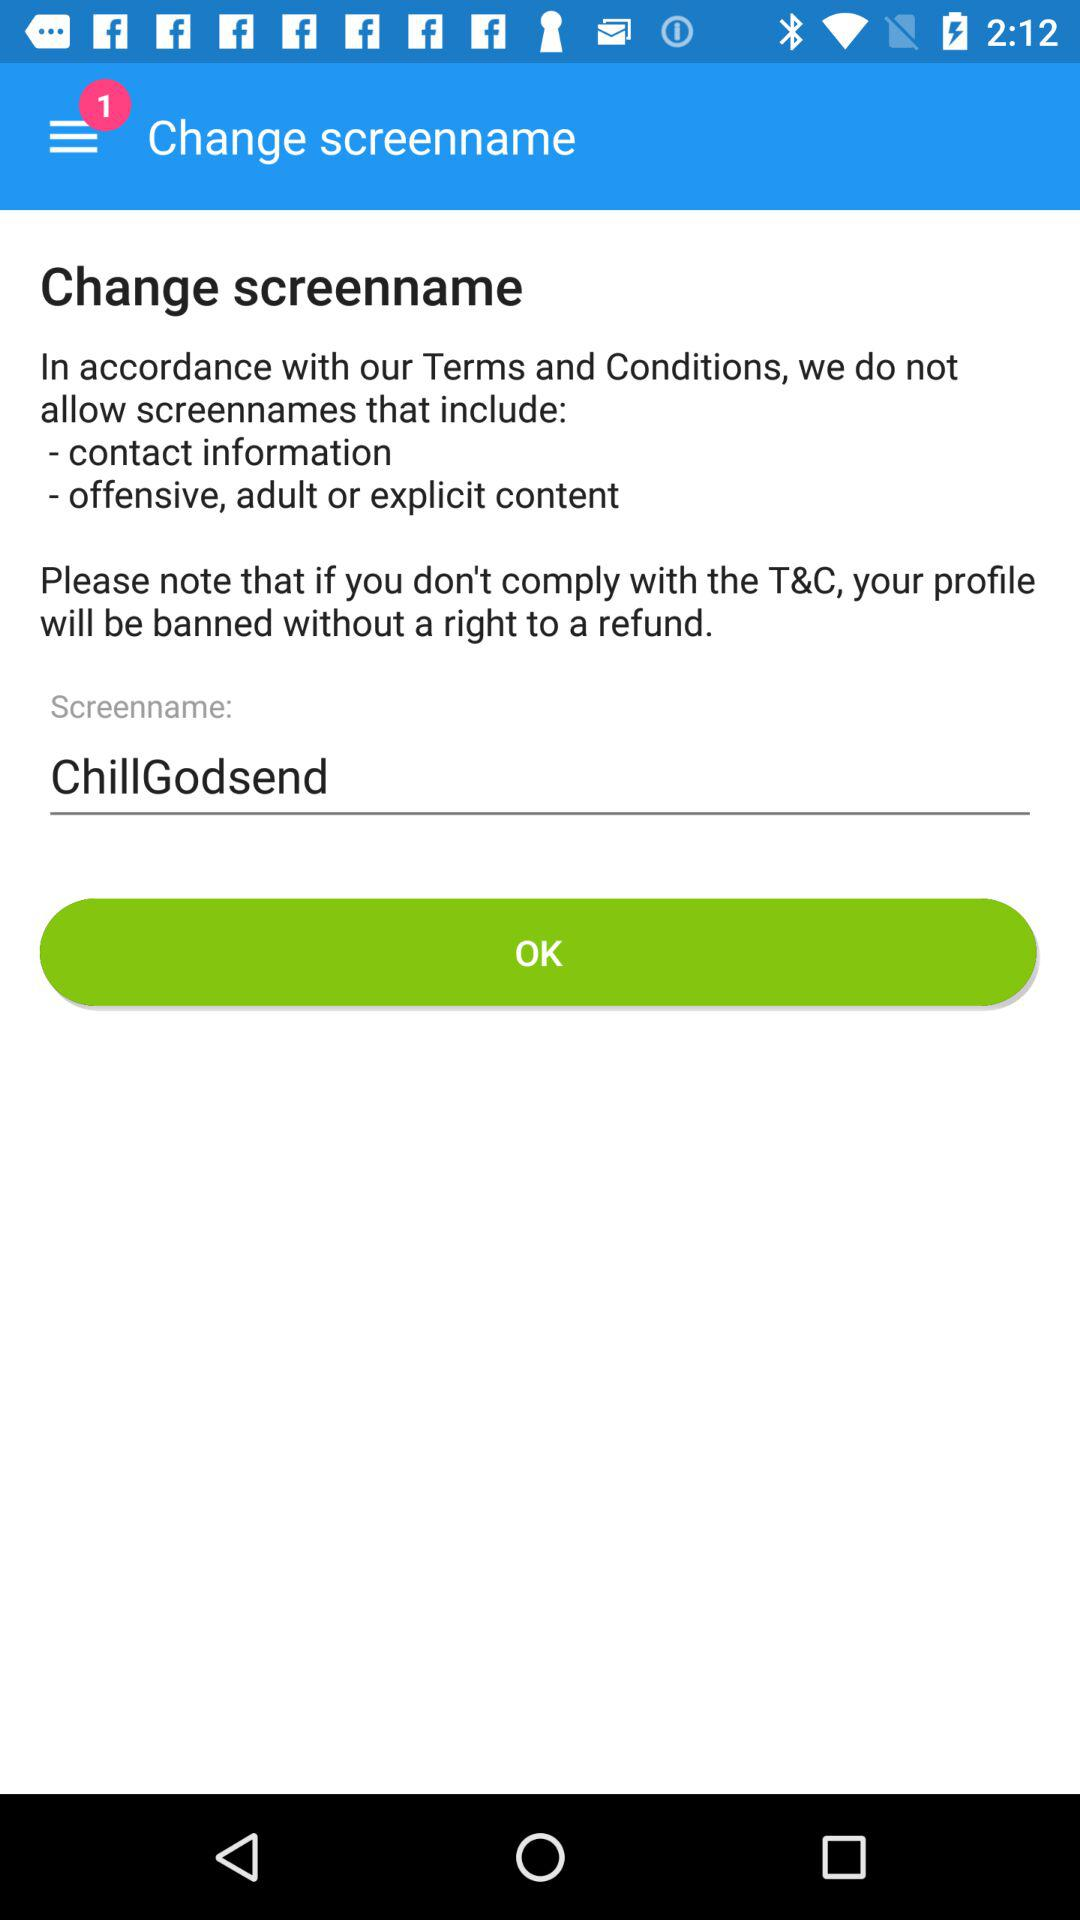Has the user agreed to the terms and conditions?
When the provided information is insufficient, respond with <no answer>. <no answer> 